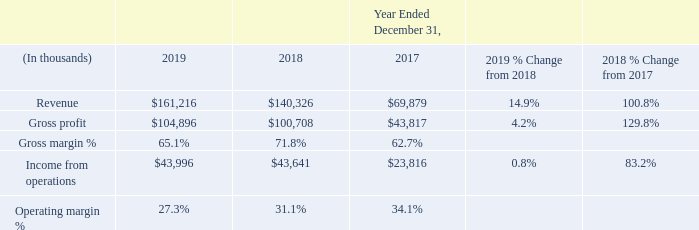Veradigm
Our Veradigm segment derives its revenue from the provision of data-driven clinical insights with actionable tools for clinical workflow, research, analytics and media. Its solutions, targeted at key healthcare stakeholders, help improve the quality, efficiency and value of healthcare delivery – from biopharma to health plans, healthcare providers and patients, and health technology partners, among others.
Year Ended December 31, 2019 Compared with the Year Ended December 31, 2018
Veradigm revenue increased during the year ended December 31, 2019 compared with the prior year comparable period due to an increase in organic sales. Gross profit and income from operations increased for during the year ended December 31, 2019 due to an increase in organic sales and cost reductions partially offset with headcount growth and hosting migration costs. The acquisition of Practice Fusion during the first quarter of 2018 also contributed to the increases.
Gross margin and operating margin decreased during the year ended December 31, 2019, compared with the prior year comparable period, primarily due to (i) an increase in hosting migration costs, (ii) costs associated with recent acquisitions, (iii) headcount growth and (iv) partially offset with other cost reductions.
Year Ended December 31, 2018 Compared with the Year Ended December 31, 2017
Veradigm revenue, gross profit, gross margin and income from operations increased during the year ended December 31, 2018 compared with the prior year comparable period primarily due to the acquisition of Practice Fusion during the first quarter of 2018. Operating margin decreased during 2018 primarily due to higher personnel costs related to incremental resources from the Practice Fusion acquisition and to support anticipated new hosting client golives.
What led to increase in Veradigm revenue during the year ended December 31, 2019? Due to an increase in organic sales. What led to increase in Gross profit and income from operations during the year ended December 31, 2019? Due to an increase in organic sales and cost reductions partially offset with headcount growth and hosting migration costs. What led to decrease in Gross margin and operating margin during the year ended December 31, 2019? (i) an increase in hosting migration costs, (ii) costs associated with recent acquisitions, (iii) headcount growth and (iv) partially offset with other cost reductions. What is the change in Revenue between 2019 and 2017?
Answer scale should be: thousand. 161,216-69,879
Answer: 91337. What is the change in Gross profit between 2019 nd 2017?
Answer scale should be: thousand. 104,896-43,817
Answer: 61079. What is the change in Income from operations between 2019 and 2017?
Answer scale should be: thousand. 43,996-23,816
Answer: 20180. 